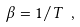<formula> <loc_0><loc_0><loc_500><loc_500>\beta = 1 / T \ ,</formula> 